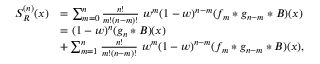Convert formula to latex. <formula><loc_0><loc_0><loc_500><loc_500>\begin{array} { r l } { S _ { R } ^ { ( n ) } ( x ) } & { = \sum _ { m = 0 } ^ { n } \frac { n ! } { m ! ( n - m ) ! } \ w ^ { m } ( 1 - w ) ^ { n - m } ( f _ { m } * g _ { n - m } * B ) ( x ) } \\ & { = ( 1 - w ) ^ { n } ( g _ { n } * B ) ( x ) } \\ & { + \sum _ { m = 1 } ^ { n } \frac { n ! } { m ! ( n - m ) ! } \ w ^ { m } ( 1 - w ) ^ { n - m } ( f _ { m } * g _ { n - m } * B ) ( x ) , } \end{array}</formula> 